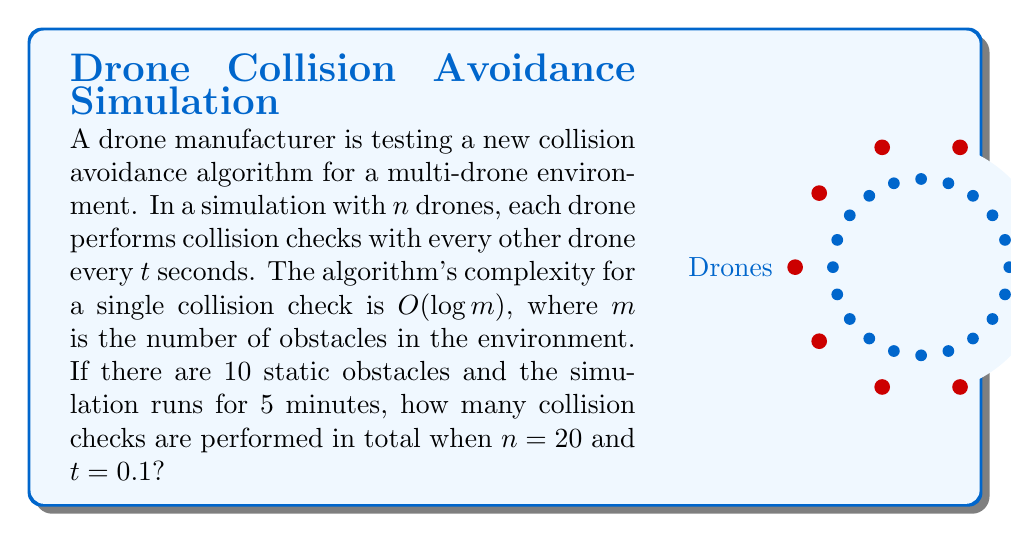Can you answer this question? Let's break this down step-by-step:

1) First, we need to calculate how many checks are performed in one second:
   - Each drone checks against $(n-1)$ other drones.
   - There are $n$ drones in total.
   - So, the number of checks per second is: $\frac{n(n-1)}{2} \cdot \frac{1}{t}$

2) Substitute the given values:
   $n = 20$, $t = 0.1$
   Checks per second = $\frac{20(20-1)}{2} \cdot \frac{1}{0.1} = 1900$

3) The simulation runs for 5 minutes, which is 300 seconds.
   Total checks = $1900 \cdot 300 = 570,000$

4) Note that the complexity of each check ($O(\log m)$) doesn't affect the number of checks performed, but rather the time each check takes. The number of obstacles ($m = 10$) is not relevant to this calculation.
Answer: 570,000 collision checks 